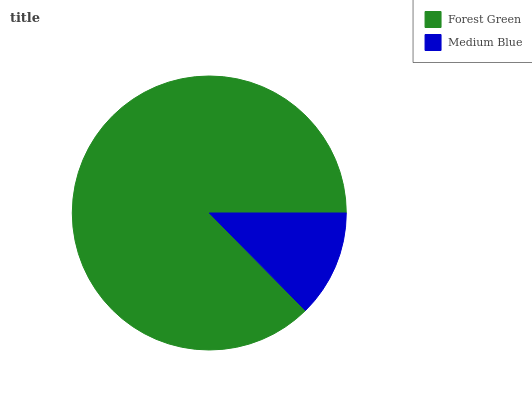Is Medium Blue the minimum?
Answer yes or no. Yes. Is Forest Green the maximum?
Answer yes or no. Yes. Is Medium Blue the maximum?
Answer yes or no. No. Is Forest Green greater than Medium Blue?
Answer yes or no. Yes. Is Medium Blue less than Forest Green?
Answer yes or no. Yes. Is Medium Blue greater than Forest Green?
Answer yes or no. No. Is Forest Green less than Medium Blue?
Answer yes or no. No. Is Forest Green the high median?
Answer yes or no. Yes. Is Medium Blue the low median?
Answer yes or no. Yes. Is Medium Blue the high median?
Answer yes or no. No. Is Forest Green the low median?
Answer yes or no. No. 